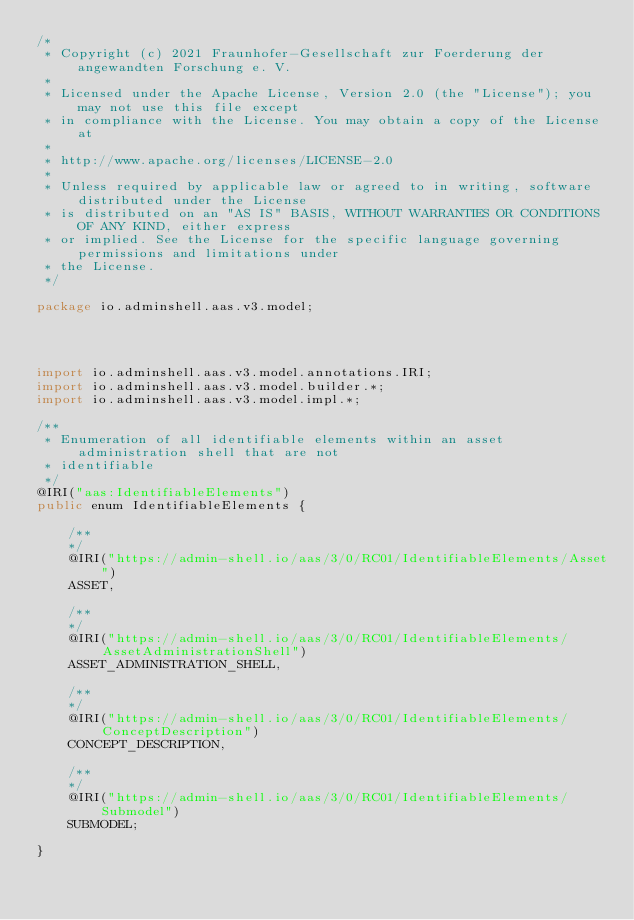Convert code to text. <code><loc_0><loc_0><loc_500><loc_500><_Java_>/*
 * Copyright (c) 2021 Fraunhofer-Gesellschaft zur Foerderung der angewandten Forschung e. V.
 * 
 * Licensed under the Apache License, Version 2.0 (the "License"); you may not use this file except
 * in compliance with the License. You may obtain a copy of the License at
 * 
 * http://www.apache.org/licenses/LICENSE-2.0
 * 
 * Unless required by applicable law or agreed to in writing, software distributed under the License
 * is distributed on an "AS IS" BASIS, WITHOUT WARRANTIES OR CONDITIONS OF ANY KIND, either express
 * or implied. See the License for the specific language governing permissions and limitations under
 * the License.
 */

package io.adminshell.aas.v3.model;




import io.adminshell.aas.v3.model.annotations.IRI;
import io.adminshell.aas.v3.model.builder.*;
import io.adminshell.aas.v3.model.impl.*;

/**
 * Enumeration of all identifiable elements within an asset administration shell that are not
 * identifiable
 */
@IRI("aas:IdentifiableElements")
public enum IdentifiableElements {

    /** 
    */
    @IRI("https://admin-shell.io/aas/3/0/RC01/IdentifiableElements/Asset")
    ASSET,

    /** 
    */
    @IRI("https://admin-shell.io/aas/3/0/RC01/IdentifiableElements/AssetAdministrationShell")
    ASSET_ADMINISTRATION_SHELL,

    /** 
    */
    @IRI("https://admin-shell.io/aas/3/0/RC01/IdentifiableElements/ConceptDescription")
    CONCEPT_DESCRIPTION,

    /** 
    */
    @IRI("https://admin-shell.io/aas/3/0/RC01/IdentifiableElements/Submodel")
    SUBMODEL;

}
</code> 